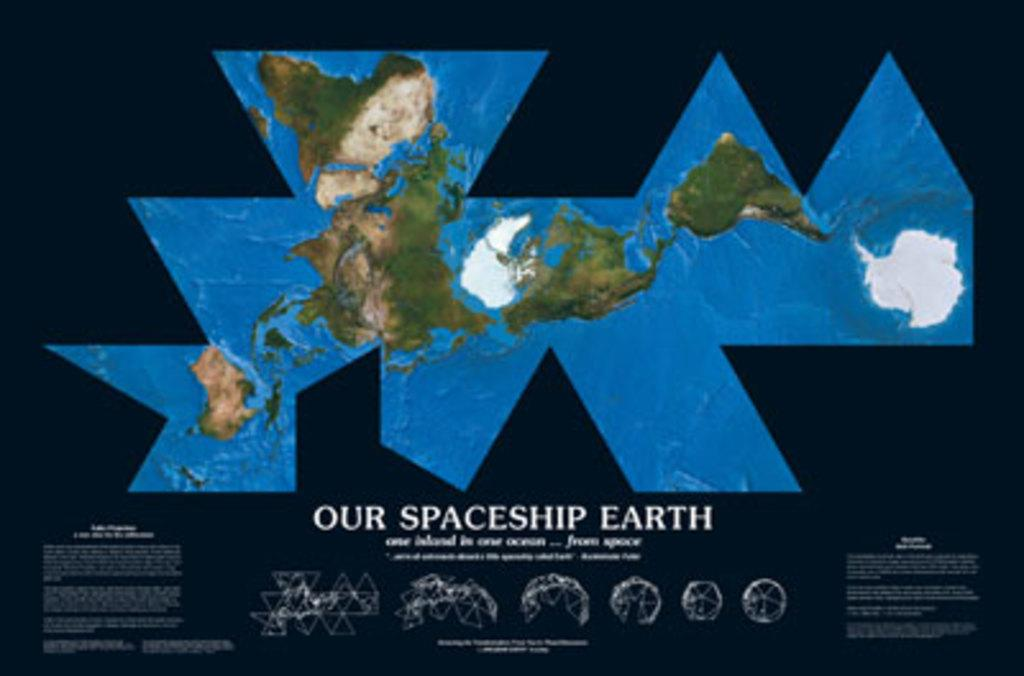Provide a one-sentence caption for the provided image. Our spaceship earth poster that includes a map. 